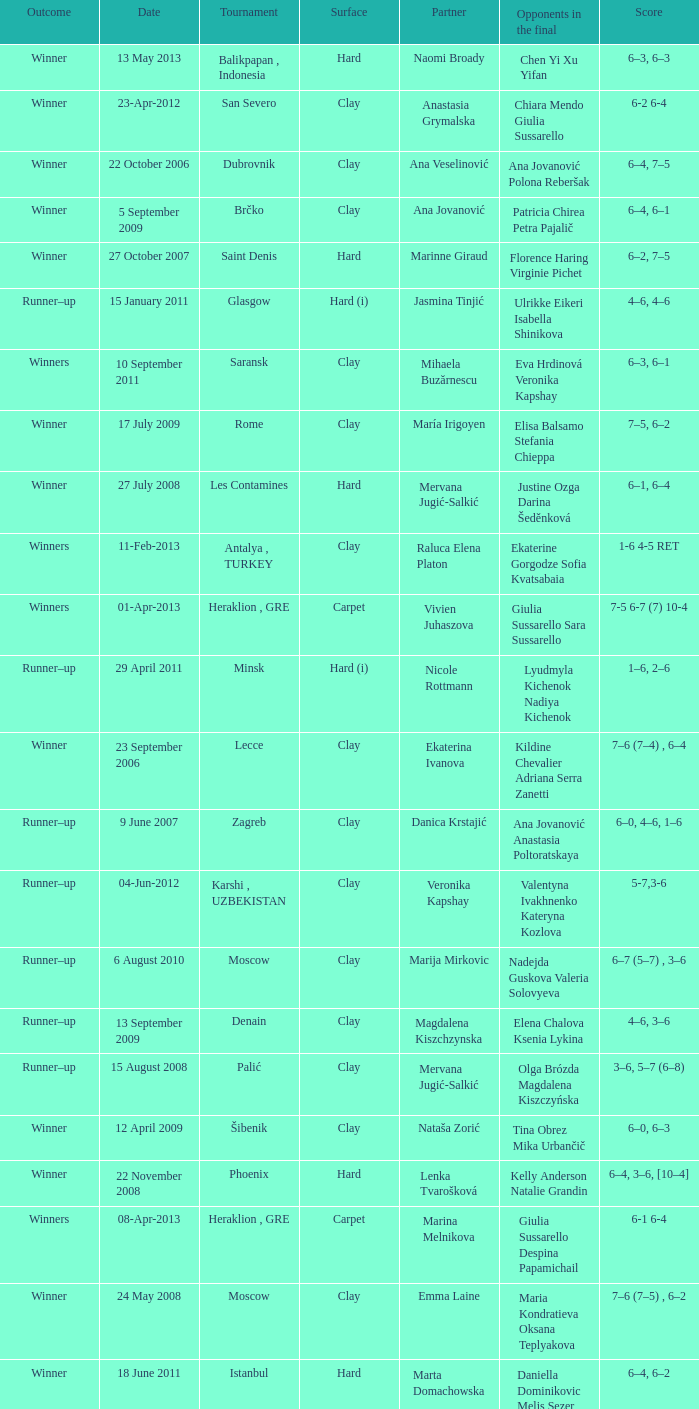Who were the opponents in the final at Noida? Kelly Anderson Chanelle Scheepers. 